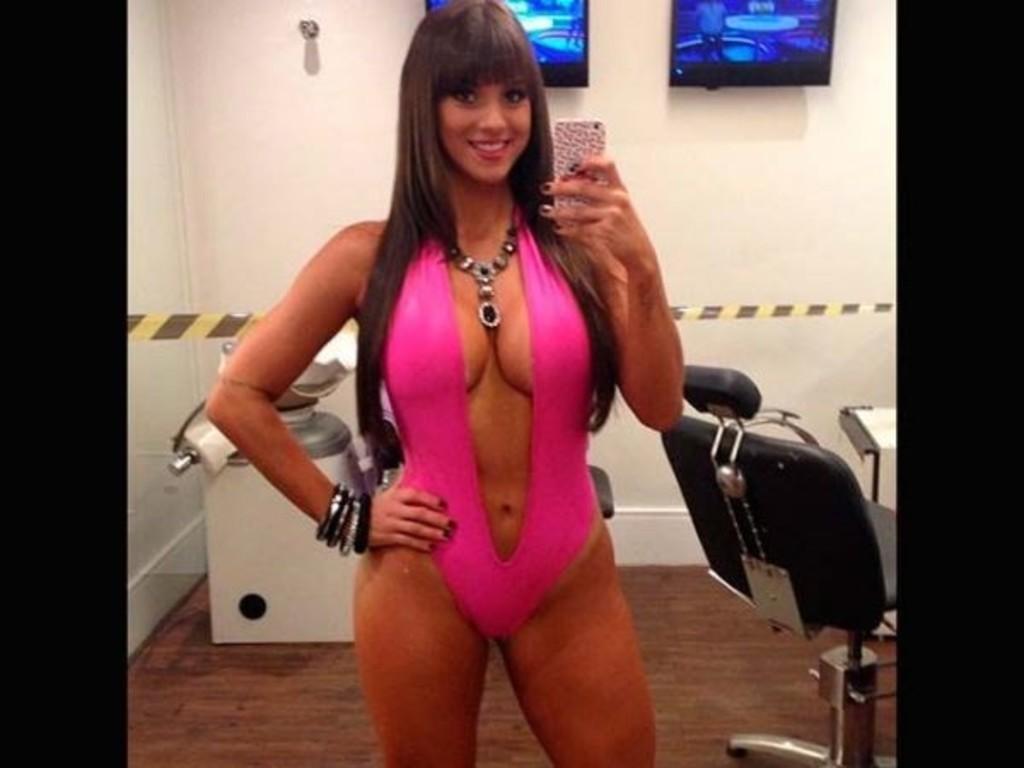How would you summarize this image in a sentence or two? In this image there is a woman who is wearing a pink color dress and necklace. She is holding a mobile in her hand. On the right there is a chair. We can see a television on a wall. On the left there is a machine. 